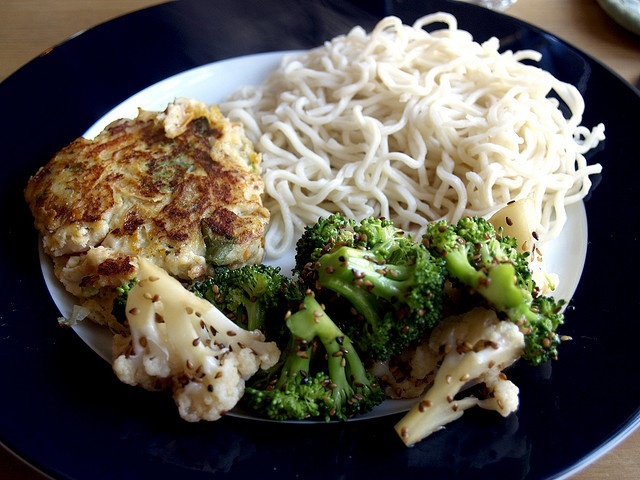Describe the objects in this image and their specific colors. I can see a broccoli in gray, black, darkgreen, and olive tones in this image. 